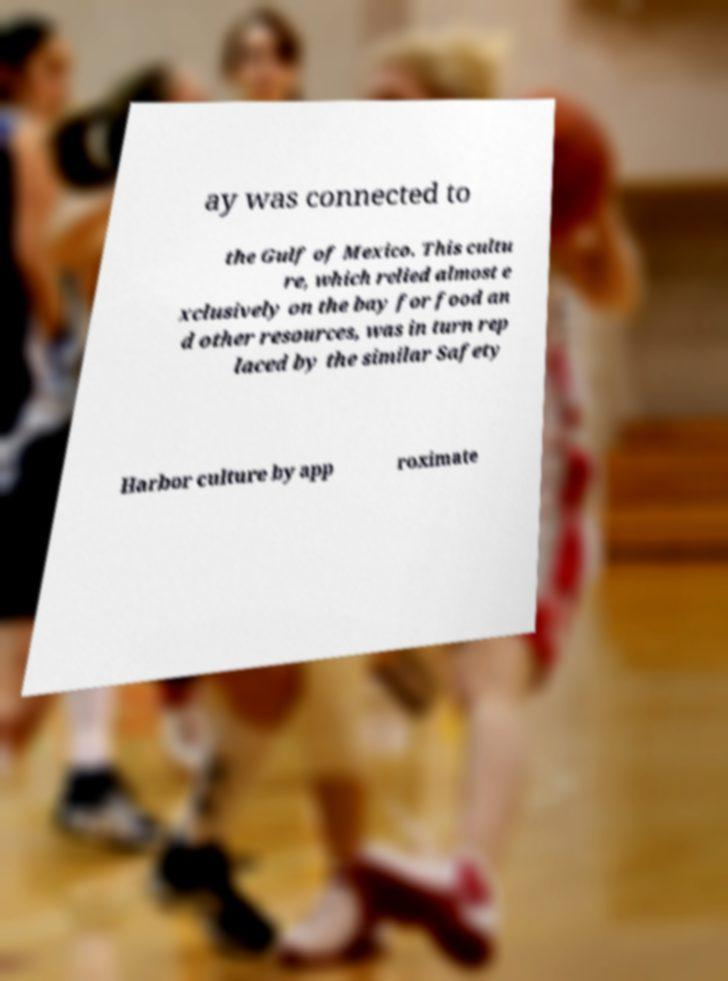For documentation purposes, I need the text within this image transcribed. Could you provide that? ay was connected to the Gulf of Mexico. This cultu re, which relied almost e xclusively on the bay for food an d other resources, was in turn rep laced by the similar Safety Harbor culture by app roximate 